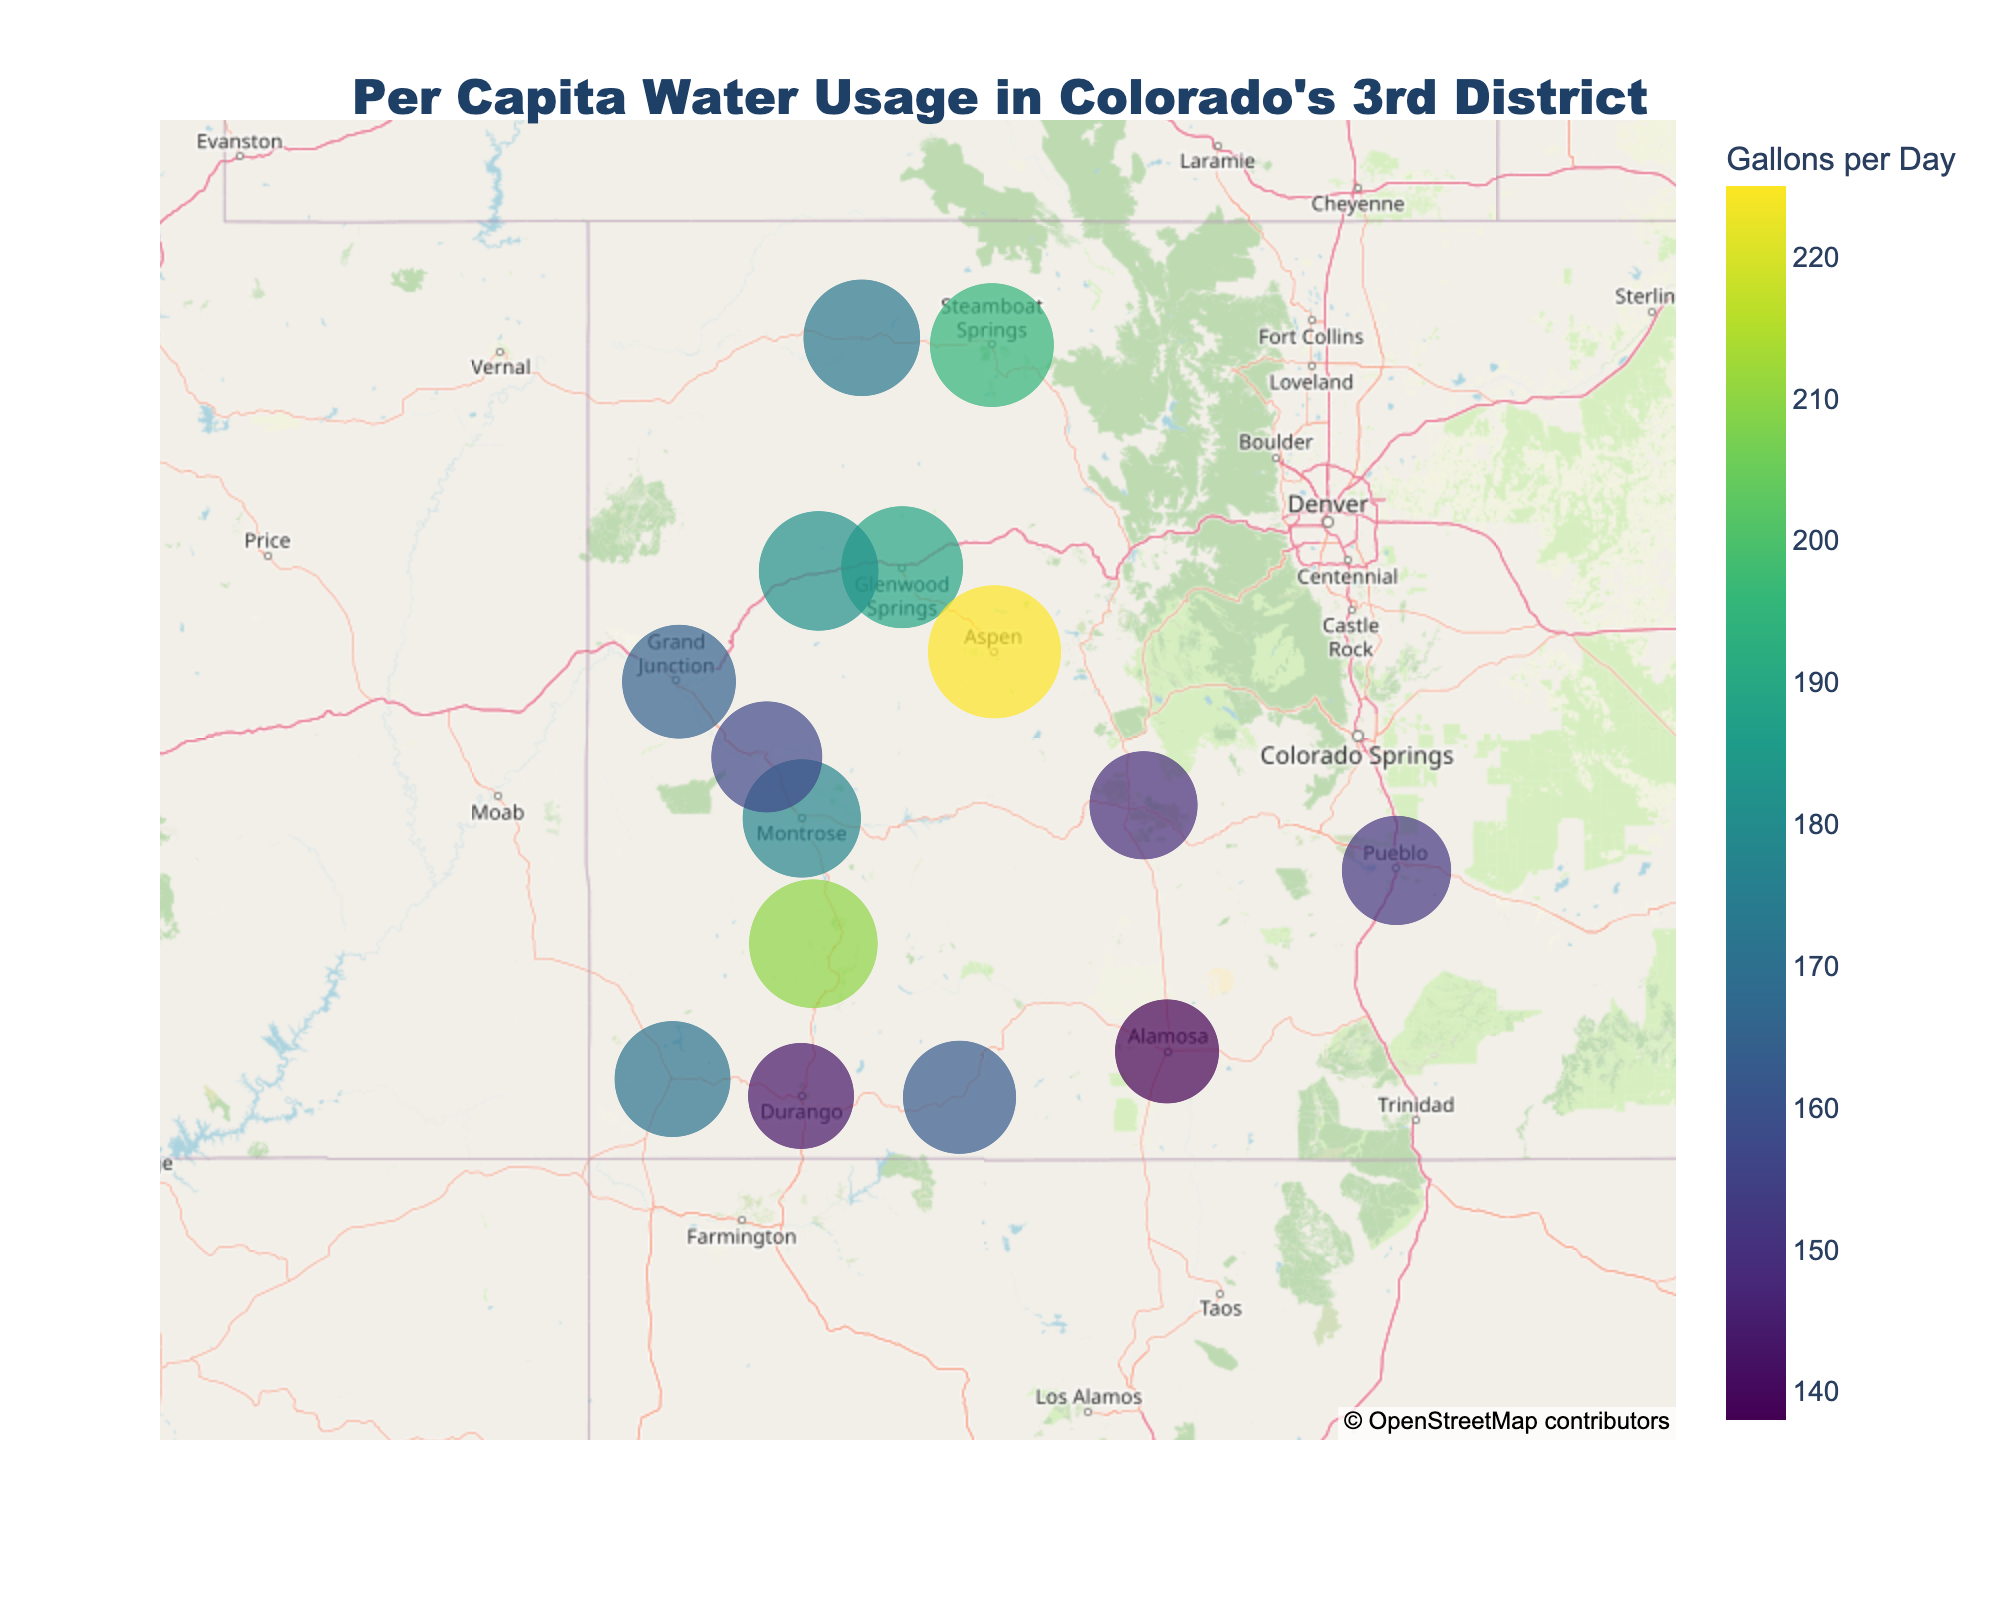Which municipality has the highest per capita water usage? Locate the municipality with the largest dot on the map and the highest numerical value in the legend.
Answer: Aspen What is the title of the figure? Read the text placed prominently at the top center of the map.
Answer: Per Capita Water Usage in Colorado's 3rd District How many municipalities have a per capita water usage greater than 180 gallons per day? Identify each data point and count those which are denoted by circles larger and darker due to usage above 180 gallons/day.
Answer: 6 What is the average per capita water usage for the municipalities listed? Sum the per capita water usage for each municipality and divide by the total number of municipalities.
Answer: (165 + 143 + 178 + 152 + 189 + 171 + 157 + 138 + 182 + 210 + 195 + 225 + 163 + 149 + 173) / 15 = 169.87 Which municipalities have the smallest and largest water usage, respectively? Identify the municipality with the smallest dot and lowest value, and the one with the largest dot and highest value based on the color intensity.
Answer: Alamosa, Aspen What color does the highest water usage municipality have on the map? Identify the color of the largest dot that corresponds to the highest value on the map.
Answer: Dark purple Which municipalities have water usage between 160 and 170 gallons per day? Look for the municipalities with dots sized and colored between 160 and 170 gallons per day according to the legend.
Answer: Grand Junction, Pagosa Springs, Delta How does Telluride's water usage compare to Durango's? Compare the size and color of the dots for Telluride and Durango.
Answer: Telluride is higher Is Pueblo's water usage below the average of all municipalities in the district? Compute the average per capita water usage (169.87 gallons/day) and compare it to the value for Pueblo (152 gallons/day).
Answer: Yes 